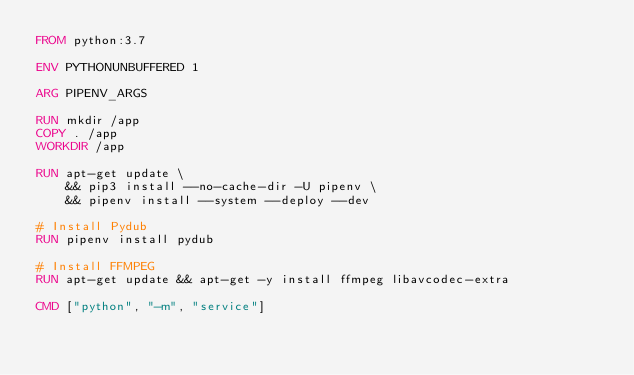Convert code to text. <code><loc_0><loc_0><loc_500><loc_500><_Dockerfile_>FROM python:3.7

ENV PYTHONUNBUFFERED 1

ARG PIPENV_ARGS

RUN mkdir /app
COPY . /app
WORKDIR /app

RUN apt-get update \
    && pip3 install --no-cache-dir -U pipenv \
    && pipenv install --system --deploy --dev

# Install Pydub
RUN pipenv install pydub

# Install FFMPEG 
RUN apt-get update && apt-get -y install ffmpeg libavcodec-extra

CMD ["python", "-m", "service"]
</code> 